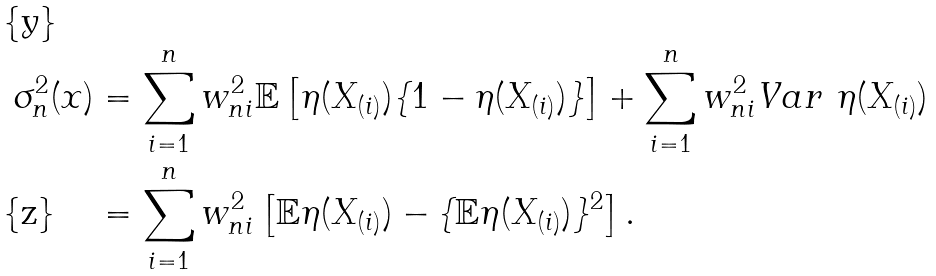Convert formula to latex. <formula><loc_0><loc_0><loc_500><loc_500>\sigma _ { n } ^ { 2 } ( x ) & = \sum _ { i = 1 } ^ { n } w _ { n i } ^ { 2 } \mathbb { E } \left [ \eta ( X _ { ( i ) } ) \{ 1 - \eta ( X _ { ( i ) } ) \} \right ] + \sum _ { i = 1 } ^ { n } w _ { n i } ^ { 2 } V a r \ \eta ( X _ { ( i ) } ) \\ & = \sum _ { i = 1 } ^ { n } w _ { n i } ^ { 2 } \left [ \mathbb { E } \eta ( X _ { ( i ) } ) - \{ \mathbb { E } \eta ( X _ { ( i ) } ) \} ^ { 2 } \right ] .</formula> 